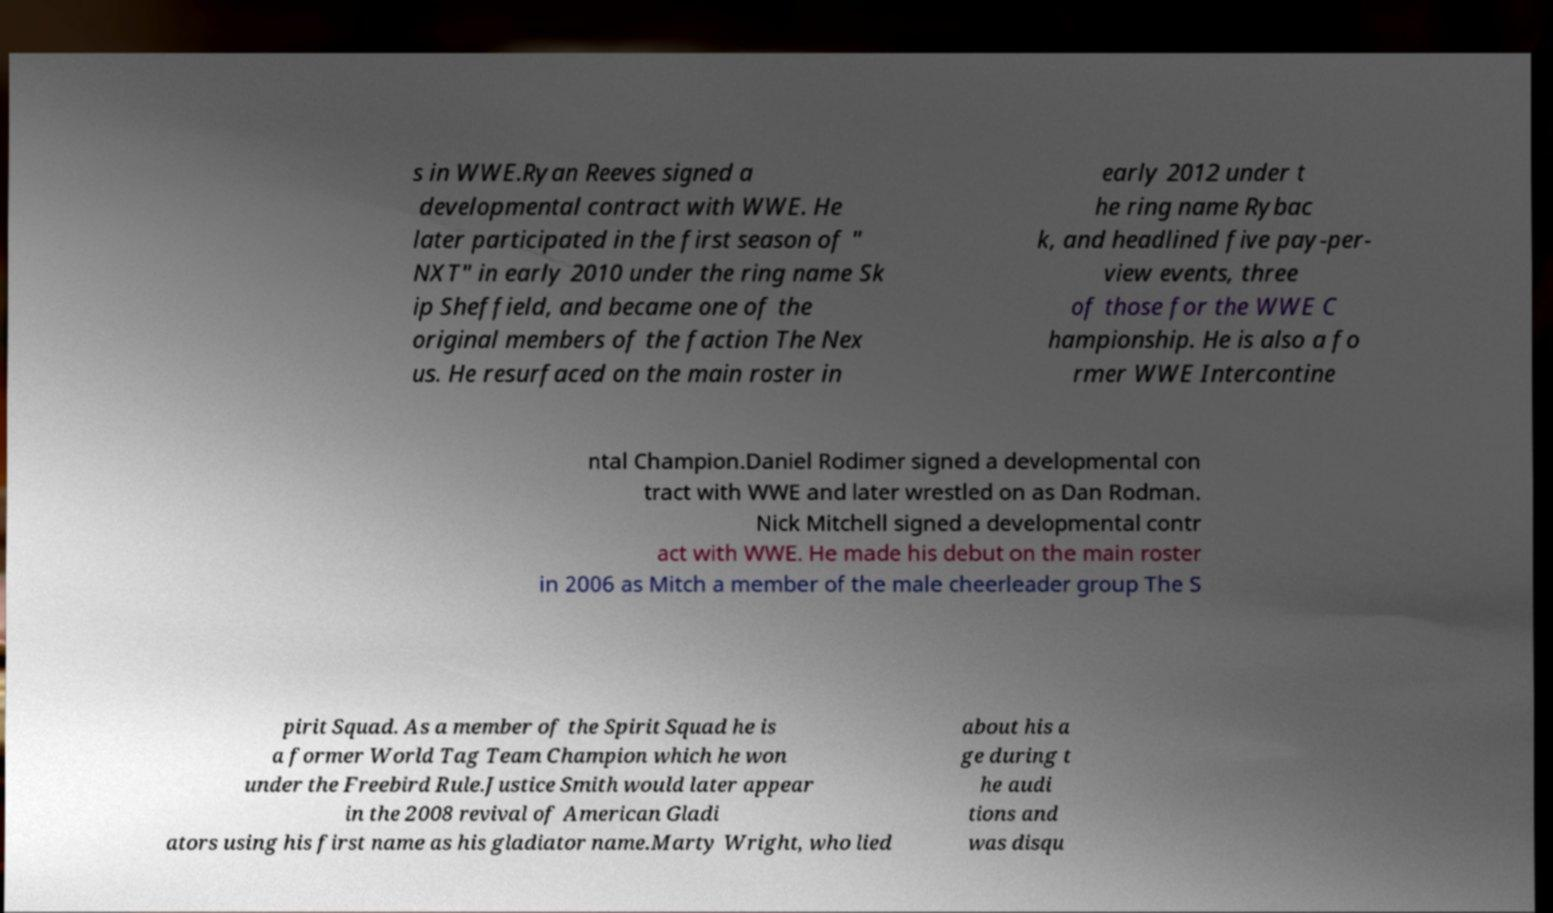I need the written content from this picture converted into text. Can you do that? s in WWE.Ryan Reeves signed a developmental contract with WWE. He later participated in the first season of " NXT" in early 2010 under the ring name Sk ip Sheffield, and became one of the original members of the faction The Nex us. He resurfaced on the main roster in early 2012 under t he ring name Rybac k, and headlined five pay-per- view events, three of those for the WWE C hampionship. He is also a fo rmer WWE Intercontine ntal Champion.Daniel Rodimer signed a developmental con tract with WWE and later wrestled on as Dan Rodman. Nick Mitchell signed a developmental contr act with WWE. He made his debut on the main roster in 2006 as Mitch a member of the male cheerleader group The S pirit Squad. As a member of the Spirit Squad he is a former World Tag Team Champion which he won under the Freebird Rule.Justice Smith would later appear in the 2008 revival of American Gladi ators using his first name as his gladiator name.Marty Wright, who lied about his a ge during t he audi tions and was disqu 